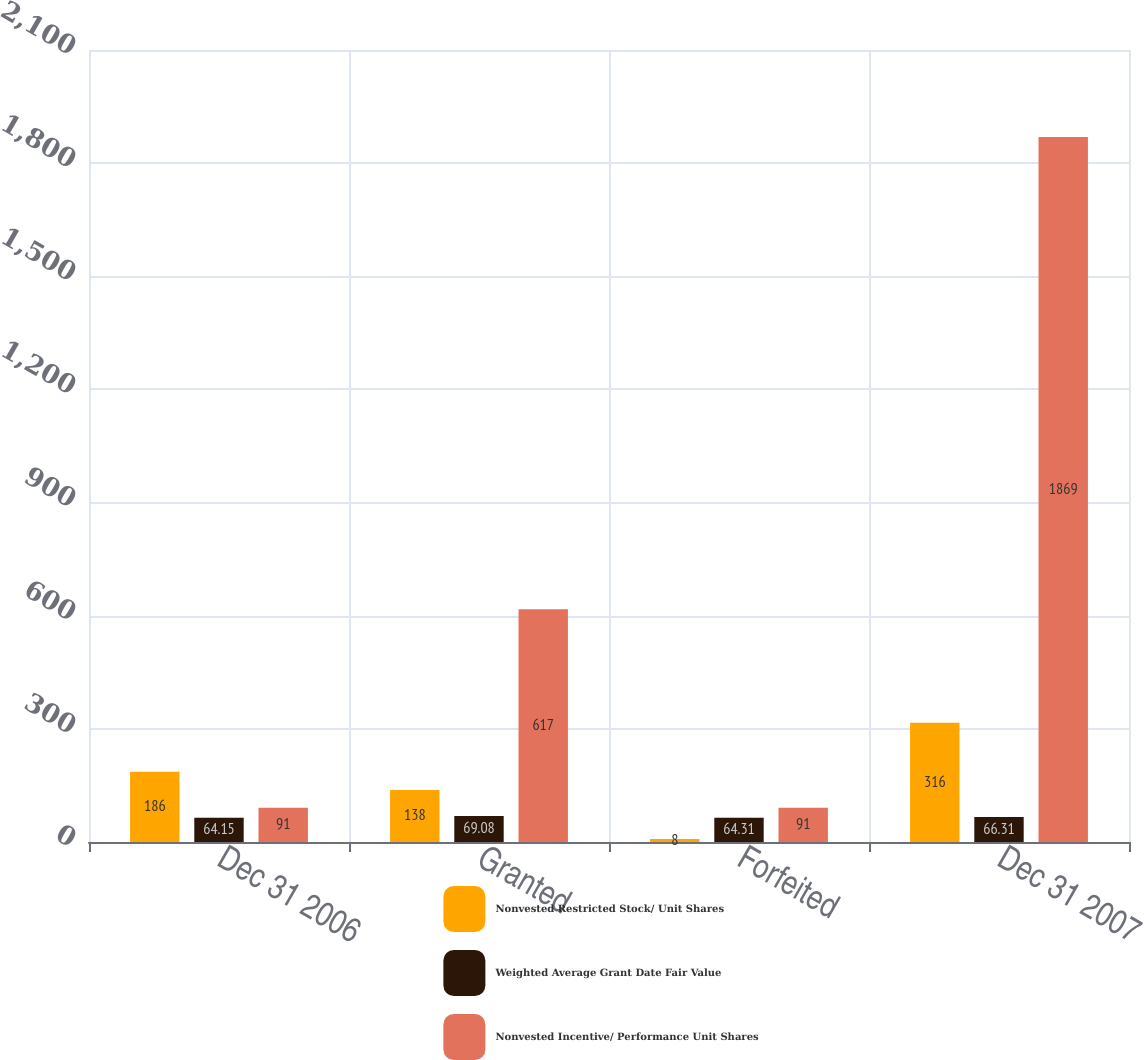Convert chart. <chart><loc_0><loc_0><loc_500><loc_500><stacked_bar_chart><ecel><fcel>Dec 31 2006<fcel>Granted<fcel>Forfeited<fcel>Dec 31 2007<nl><fcel>Nonvested Restricted Stock/ Unit Shares<fcel>186<fcel>138<fcel>8<fcel>316<nl><fcel>Weighted Average Grant Date Fair Value<fcel>64.15<fcel>69.08<fcel>64.31<fcel>66.31<nl><fcel>Nonvested Incentive/ Performance Unit Shares<fcel>91<fcel>617<fcel>91<fcel>1869<nl></chart> 